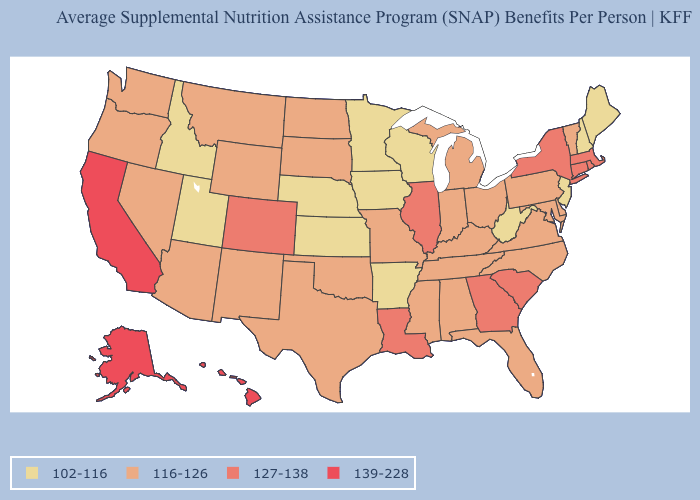Among the states that border Utah , which have the highest value?
Be succinct. Colorado. Which states have the lowest value in the USA?
Concise answer only. Arkansas, Idaho, Iowa, Kansas, Maine, Minnesota, Nebraska, New Hampshire, New Jersey, Utah, West Virginia, Wisconsin. What is the value of New Mexico?
Concise answer only. 116-126. What is the value of Alaska?
Concise answer only. 139-228. Name the states that have a value in the range 127-138?
Answer briefly. Colorado, Connecticut, Georgia, Illinois, Louisiana, Massachusetts, New York, Rhode Island, South Carolina. Among the states that border North Carolina , which have the highest value?
Give a very brief answer. Georgia, South Carolina. What is the lowest value in the USA?
Short answer required. 102-116. What is the highest value in the Northeast ?
Short answer required. 127-138. Which states hav the highest value in the South?
Short answer required. Georgia, Louisiana, South Carolina. What is the value of Maryland?
Keep it brief. 116-126. Is the legend a continuous bar?
Write a very short answer. No. Name the states that have a value in the range 139-228?
Keep it brief. Alaska, California, Hawaii. What is the value of New Mexico?
Be succinct. 116-126. Among the states that border Arkansas , does Tennessee have the highest value?
Be succinct. No. 